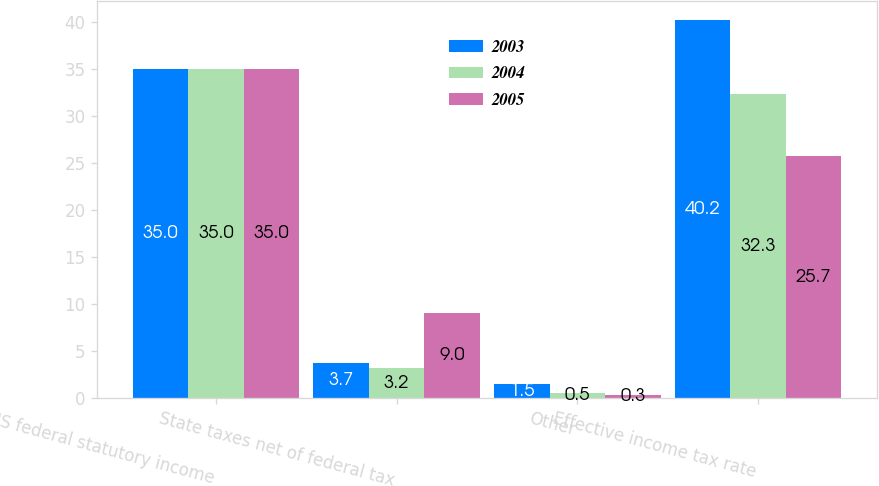Convert chart to OTSL. <chart><loc_0><loc_0><loc_500><loc_500><stacked_bar_chart><ecel><fcel>US federal statutory income<fcel>State taxes net of federal tax<fcel>Other<fcel>Effective income tax rate<nl><fcel>2003<fcel>35<fcel>3.7<fcel>1.5<fcel>40.2<nl><fcel>2004<fcel>35<fcel>3.2<fcel>0.5<fcel>32.3<nl><fcel>2005<fcel>35<fcel>9<fcel>0.3<fcel>25.7<nl></chart> 